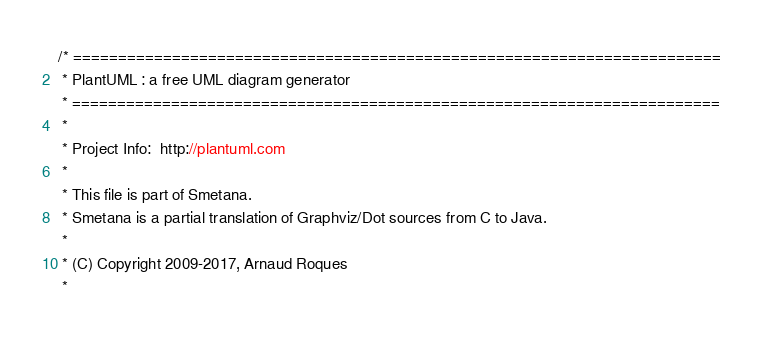<code> <loc_0><loc_0><loc_500><loc_500><_Java_>/* ========================================================================
 * PlantUML : a free UML diagram generator
 * ========================================================================
 *
 * Project Info:  http://plantuml.com
 * 
 * This file is part of Smetana.
 * Smetana is a partial translation of Graphviz/Dot sources from C to Java.
 *
 * (C) Copyright 2009-2017, Arnaud Roques
 *</code> 